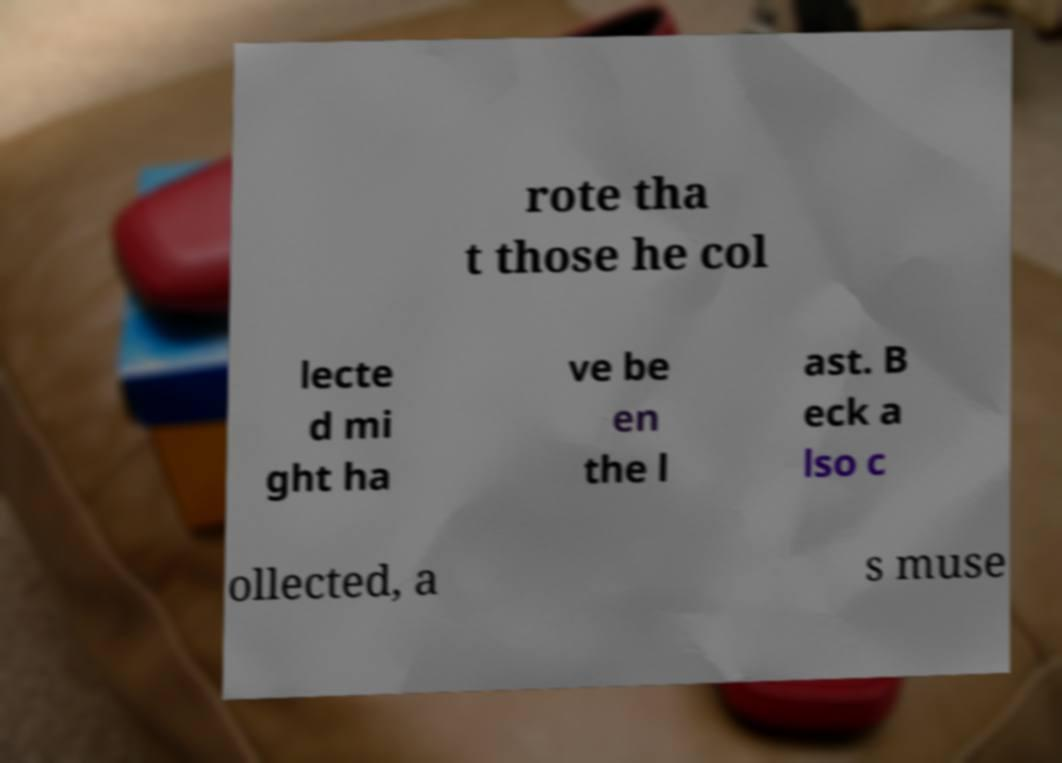I need the written content from this picture converted into text. Can you do that? rote tha t those he col lecte d mi ght ha ve be en the l ast. B eck a lso c ollected, a s muse 